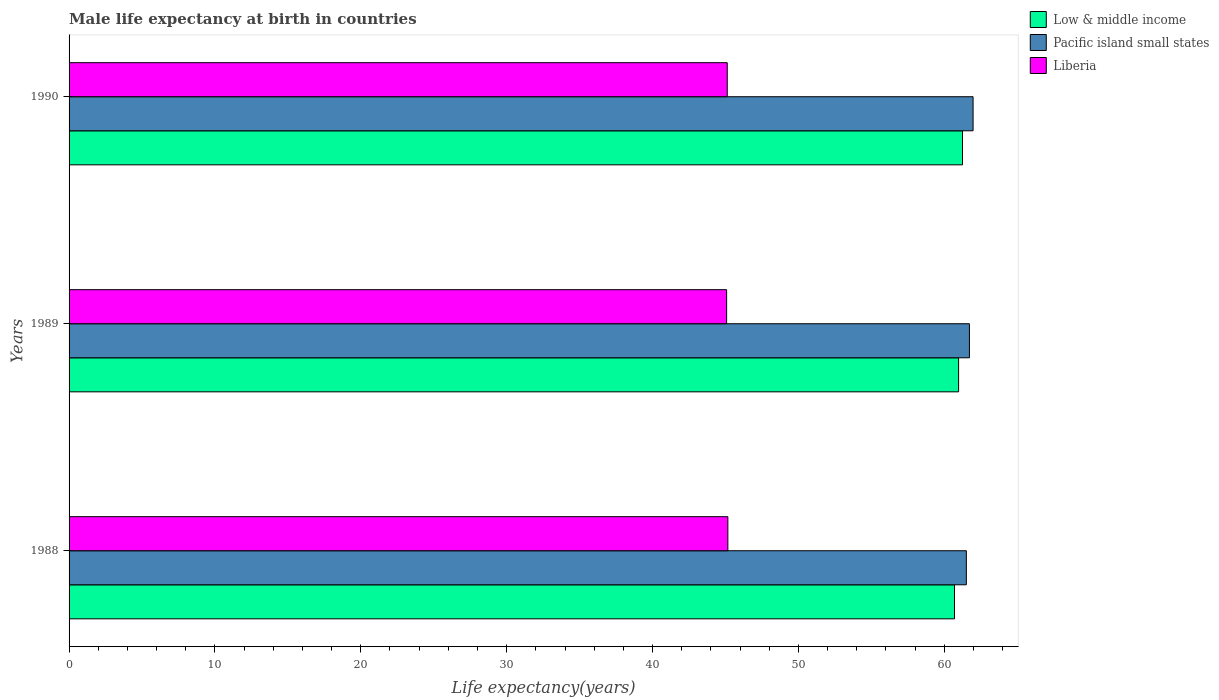How many different coloured bars are there?
Ensure brevity in your answer.  3. How many groups of bars are there?
Make the answer very short. 3. Are the number of bars on each tick of the Y-axis equal?
Ensure brevity in your answer.  Yes. How many bars are there on the 1st tick from the bottom?
Make the answer very short. 3. In how many cases, is the number of bars for a given year not equal to the number of legend labels?
Offer a very short reply. 0. What is the male life expectancy at birth in Low & middle income in 1988?
Provide a succinct answer. 60.7. Across all years, what is the maximum male life expectancy at birth in Low & middle income?
Offer a terse response. 61.25. Across all years, what is the minimum male life expectancy at birth in Pacific island small states?
Keep it short and to the point. 61.51. In which year was the male life expectancy at birth in Low & middle income maximum?
Ensure brevity in your answer.  1990. In which year was the male life expectancy at birth in Pacific island small states minimum?
Make the answer very short. 1988. What is the total male life expectancy at birth in Low & middle income in the graph?
Your answer should be compact. 182.93. What is the difference between the male life expectancy at birth in Liberia in 1988 and that in 1990?
Offer a terse response. 0.04. What is the difference between the male life expectancy at birth in Liberia in 1990 and the male life expectancy at birth in Low & middle income in 1988?
Offer a terse response. -15.58. What is the average male life expectancy at birth in Liberia per year?
Your answer should be compact. 45.12. In the year 1988, what is the difference between the male life expectancy at birth in Liberia and male life expectancy at birth in Pacific island small states?
Make the answer very short. -16.35. In how many years, is the male life expectancy at birth in Low & middle income greater than 14 years?
Ensure brevity in your answer.  3. What is the ratio of the male life expectancy at birth in Liberia in 1989 to that in 1990?
Give a very brief answer. 1. Is the difference between the male life expectancy at birth in Liberia in 1989 and 1990 greater than the difference between the male life expectancy at birth in Pacific island small states in 1989 and 1990?
Your response must be concise. Yes. What is the difference between the highest and the second highest male life expectancy at birth in Low & middle income?
Keep it short and to the point. 0.27. What is the difference between the highest and the lowest male life expectancy at birth in Pacific island small states?
Ensure brevity in your answer.  0.46. Is the sum of the male life expectancy at birth in Low & middle income in 1988 and 1990 greater than the maximum male life expectancy at birth in Liberia across all years?
Your response must be concise. Yes. What does the 1st bar from the top in 1988 represents?
Your response must be concise. Liberia. What does the 3rd bar from the bottom in 1989 represents?
Provide a short and direct response. Liberia. How many bars are there?
Ensure brevity in your answer.  9. Are all the bars in the graph horizontal?
Provide a succinct answer. Yes. How many years are there in the graph?
Your answer should be compact. 3. Are the values on the major ticks of X-axis written in scientific E-notation?
Give a very brief answer. No. Does the graph contain grids?
Ensure brevity in your answer.  No. How are the legend labels stacked?
Offer a very short reply. Vertical. What is the title of the graph?
Offer a terse response. Male life expectancy at birth in countries. Does "Paraguay" appear as one of the legend labels in the graph?
Make the answer very short. No. What is the label or title of the X-axis?
Your answer should be very brief. Life expectancy(years). What is the label or title of the Y-axis?
Give a very brief answer. Years. What is the Life expectancy(years) of Low & middle income in 1988?
Give a very brief answer. 60.7. What is the Life expectancy(years) in Pacific island small states in 1988?
Give a very brief answer. 61.51. What is the Life expectancy(years) in Liberia in 1988?
Provide a succinct answer. 45.16. What is the Life expectancy(years) in Low & middle income in 1989?
Offer a very short reply. 60.98. What is the Life expectancy(years) of Pacific island small states in 1989?
Your answer should be compact. 61.72. What is the Life expectancy(years) of Liberia in 1989?
Your response must be concise. 45.08. What is the Life expectancy(years) of Low & middle income in 1990?
Your answer should be very brief. 61.25. What is the Life expectancy(years) in Pacific island small states in 1990?
Ensure brevity in your answer.  61.97. What is the Life expectancy(years) of Liberia in 1990?
Give a very brief answer. 45.12. Across all years, what is the maximum Life expectancy(years) of Low & middle income?
Your response must be concise. 61.25. Across all years, what is the maximum Life expectancy(years) in Pacific island small states?
Your answer should be compact. 61.97. Across all years, what is the maximum Life expectancy(years) of Liberia?
Give a very brief answer. 45.16. Across all years, what is the minimum Life expectancy(years) of Low & middle income?
Provide a succinct answer. 60.7. Across all years, what is the minimum Life expectancy(years) of Pacific island small states?
Provide a short and direct response. 61.51. Across all years, what is the minimum Life expectancy(years) of Liberia?
Give a very brief answer. 45.08. What is the total Life expectancy(years) in Low & middle income in the graph?
Your response must be concise. 182.93. What is the total Life expectancy(years) of Pacific island small states in the graph?
Make the answer very short. 185.2. What is the total Life expectancy(years) in Liberia in the graph?
Make the answer very short. 135.36. What is the difference between the Life expectancy(years) in Low & middle income in 1988 and that in 1989?
Provide a short and direct response. -0.28. What is the difference between the Life expectancy(years) of Pacific island small states in 1988 and that in 1989?
Ensure brevity in your answer.  -0.21. What is the difference between the Life expectancy(years) in Liberia in 1988 and that in 1989?
Make the answer very short. 0.09. What is the difference between the Life expectancy(years) of Low & middle income in 1988 and that in 1990?
Offer a very short reply. -0.55. What is the difference between the Life expectancy(years) of Pacific island small states in 1988 and that in 1990?
Provide a short and direct response. -0.46. What is the difference between the Life expectancy(years) in Liberia in 1988 and that in 1990?
Ensure brevity in your answer.  0.04. What is the difference between the Life expectancy(years) of Low & middle income in 1989 and that in 1990?
Offer a terse response. -0.27. What is the difference between the Life expectancy(years) of Pacific island small states in 1989 and that in 1990?
Offer a terse response. -0.25. What is the difference between the Life expectancy(years) in Liberia in 1989 and that in 1990?
Make the answer very short. -0.04. What is the difference between the Life expectancy(years) in Low & middle income in 1988 and the Life expectancy(years) in Pacific island small states in 1989?
Provide a succinct answer. -1.02. What is the difference between the Life expectancy(years) of Low & middle income in 1988 and the Life expectancy(years) of Liberia in 1989?
Provide a short and direct response. 15.62. What is the difference between the Life expectancy(years) of Pacific island small states in 1988 and the Life expectancy(years) of Liberia in 1989?
Give a very brief answer. 16.43. What is the difference between the Life expectancy(years) in Low & middle income in 1988 and the Life expectancy(years) in Pacific island small states in 1990?
Offer a very short reply. -1.27. What is the difference between the Life expectancy(years) of Low & middle income in 1988 and the Life expectancy(years) of Liberia in 1990?
Your answer should be compact. 15.58. What is the difference between the Life expectancy(years) of Pacific island small states in 1988 and the Life expectancy(years) of Liberia in 1990?
Provide a short and direct response. 16.39. What is the difference between the Life expectancy(years) of Low & middle income in 1989 and the Life expectancy(years) of Pacific island small states in 1990?
Your response must be concise. -0.99. What is the difference between the Life expectancy(years) in Low & middle income in 1989 and the Life expectancy(years) in Liberia in 1990?
Provide a succinct answer. 15.86. What is the difference between the Life expectancy(years) of Pacific island small states in 1989 and the Life expectancy(years) of Liberia in 1990?
Keep it short and to the point. 16.6. What is the average Life expectancy(years) in Low & middle income per year?
Give a very brief answer. 60.98. What is the average Life expectancy(years) in Pacific island small states per year?
Your answer should be very brief. 61.73. What is the average Life expectancy(years) of Liberia per year?
Your response must be concise. 45.12. In the year 1988, what is the difference between the Life expectancy(years) in Low & middle income and Life expectancy(years) in Pacific island small states?
Your answer should be very brief. -0.81. In the year 1988, what is the difference between the Life expectancy(years) in Low & middle income and Life expectancy(years) in Liberia?
Give a very brief answer. 15.54. In the year 1988, what is the difference between the Life expectancy(years) of Pacific island small states and Life expectancy(years) of Liberia?
Your response must be concise. 16.35. In the year 1989, what is the difference between the Life expectancy(years) in Low & middle income and Life expectancy(years) in Pacific island small states?
Offer a very short reply. -0.74. In the year 1989, what is the difference between the Life expectancy(years) of Low & middle income and Life expectancy(years) of Liberia?
Offer a terse response. 15.9. In the year 1989, what is the difference between the Life expectancy(years) in Pacific island small states and Life expectancy(years) in Liberia?
Keep it short and to the point. 16.64. In the year 1990, what is the difference between the Life expectancy(years) of Low & middle income and Life expectancy(years) of Pacific island small states?
Your answer should be very brief. -0.72. In the year 1990, what is the difference between the Life expectancy(years) of Low & middle income and Life expectancy(years) of Liberia?
Ensure brevity in your answer.  16.13. In the year 1990, what is the difference between the Life expectancy(years) in Pacific island small states and Life expectancy(years) in Liberia?
Offer a very short reply. 16.85. What is the ratio of the Life expectancy(years) in Low & middle income in 1988 to that in 1989?
Provide a short and direct response. 1. What is the ratio of the Life expectancy(years) in Low & middle income in 1989 to that in 1990?
Your answer should be very brief. 1. What is the difference between the highest and the second highest Life expectancy(years) in Low & middle income?
Keep it short and to the point. 0.27. What is the difference between the highest and the second highest Life expectancy(years) in Pacific island small states?
Ensure brevity in your answer.  0.25. What is the difference between the highest and the second highest Life expectancy(years) of Liberia?
Your response must be concise. 0.04. What is the difference between the highest and the lowest Life expectancy(years) of Low & middle income?
Your answer should be compact. 0.55. What is the difference between the highest and the lowest Life expectancy(years) in Pacific island small states?
Give a very brief answer. 0.46. What is the difference between the highest and the lowest Life expectancy(years) of Liberia?
Keep it short and to the point. 0.09. 